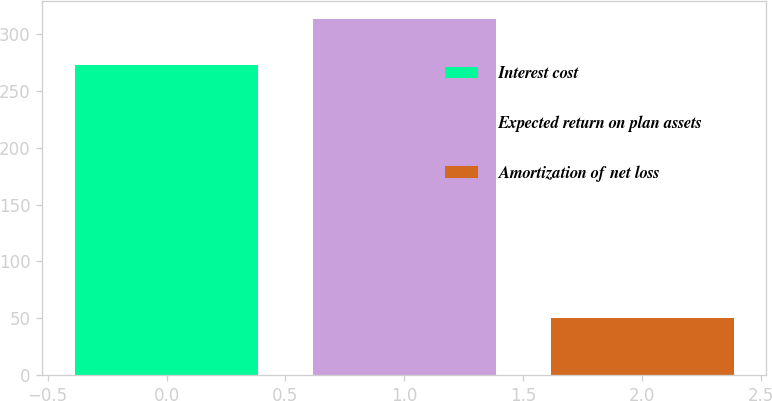Convert chart to OTSL. <chart><loc_0><loc_0><loc_500><loc_500><bar_chart><fcel>Interest cost<fcel>Expected return on plan assets<fcel>Amortization of net loss<nl><fcel>273<fcel>314<fcel>50<nl></chart> 